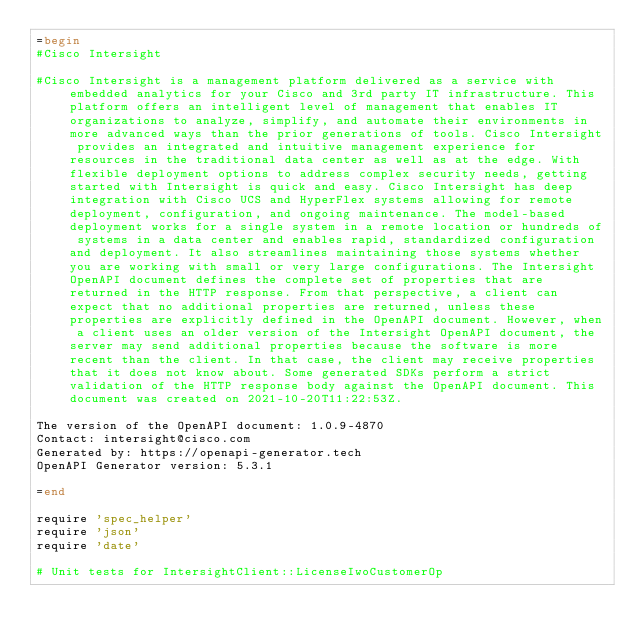<code> <loc_0><loc_0><loc_500><loc_500><_Ruby_>=begin
#Cisco Intersight

#Cisco Intersight is a management platform delivered as a service with embedded analytics for your Cisco and 3rd party IT infrastructure. This platform offers an intelligent level of management that enables IT organizations to analyze, simplify, and automate their environments in more advanced ways than the prior generations of tools. Cisco Intersight provides an integrated and intuitive management experience for resources in the traditional data center as well as at the edge. With flexible deployment options to address complex security needs, getting started with Intersight is quick and easy. Cisco Intersight has deep integration with Cisco UCS and HyperFlex systems allowing for remote deployment, configuration, and ongoing maintenance. The model-based deployment works for a single system in a remote location or hundreds of systems in a data center and enables rapid, standardized configuration and deployment. It also streamlines maintaining those systems whether you are working with small or very large configurations. The Intersight OpenAPI document defines the complete set of properties that are returned in the HTTP response. From that perspective, a client can expect that no additional properties are returned, unless these properties are explicitly defined in the OpenAPI document. However, when a client uses an older version of the Intersight OpenAPI document, the server may send additional properties because the software is more recent than the client. In that case, the client may receive properties that it does not know about. Some generated SDKs perform a strict validation of the HTTP response body against the OpenAPI document. This document was created on 2021-10-20T11:22:53Z.

The version of the OpenAPI document: 1.0.9-4870
Contact: intersight@cisco.com
Generated by: https://openapi-generator.tech
OpenAPI Generator version: 5.3.1

=end

require 'spec_helper'
require 'json'
require 'date'

# Unit tests for IntersightClient::LicenseIwoCustomerOp</code> 